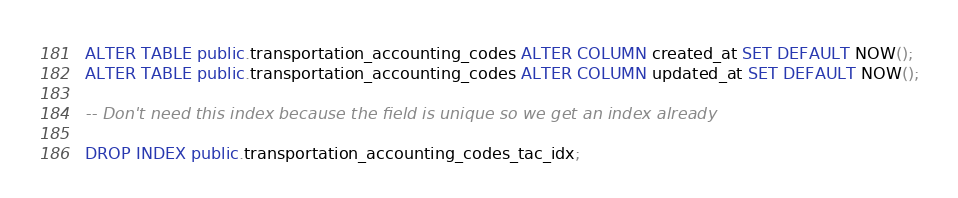<code> <loc_0><loc_0><loc_500><loc_500><_SQL_>ALTER TABLE public.transportation_accounting_codes ALTER COLUMN created_at SET DEFAULT NOW();
ALTER TABLE public.transportation_accounting_codes ALTER COLUMN updated_at SET DEFAULT NOW();

-- Don't need this index because the field is unique so we get an index already

DROP INDEX public.transportation_accounting_codes_tac_idx;
</code> 